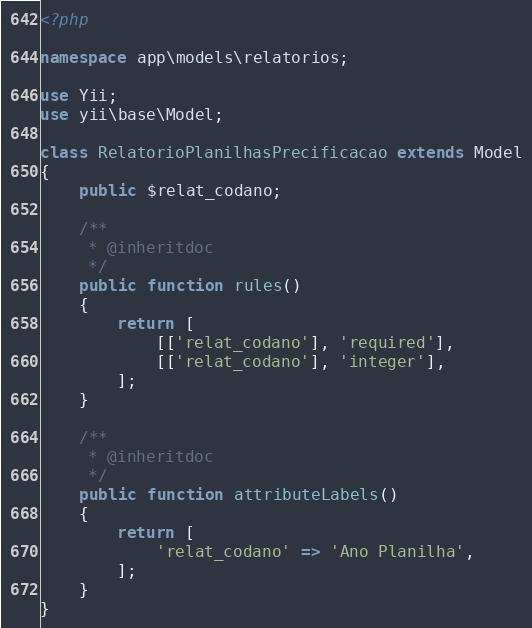<code> <loc_0><loc_0><loc_500><loc_500><_PHP_><?php

namespace app\models\relatorios;

use Yii;
use yii\base\Model;

class RelatorioPlanilhasPrecificacao extends Model
{
    public $relat_codano;

    /**
     * @inheritdoc
     */
    public function rules()
    {
        return [
            [['relat_codano'], 'required'],
            [['relat_codano'], 'integer'],
        ];
    }

    /**
     * @inheritdoc
     */
    public function attributeLabels()
    {
        return [
            'relat_codano' => 'Ano Planilha',
        ];
    }
}
</code> 